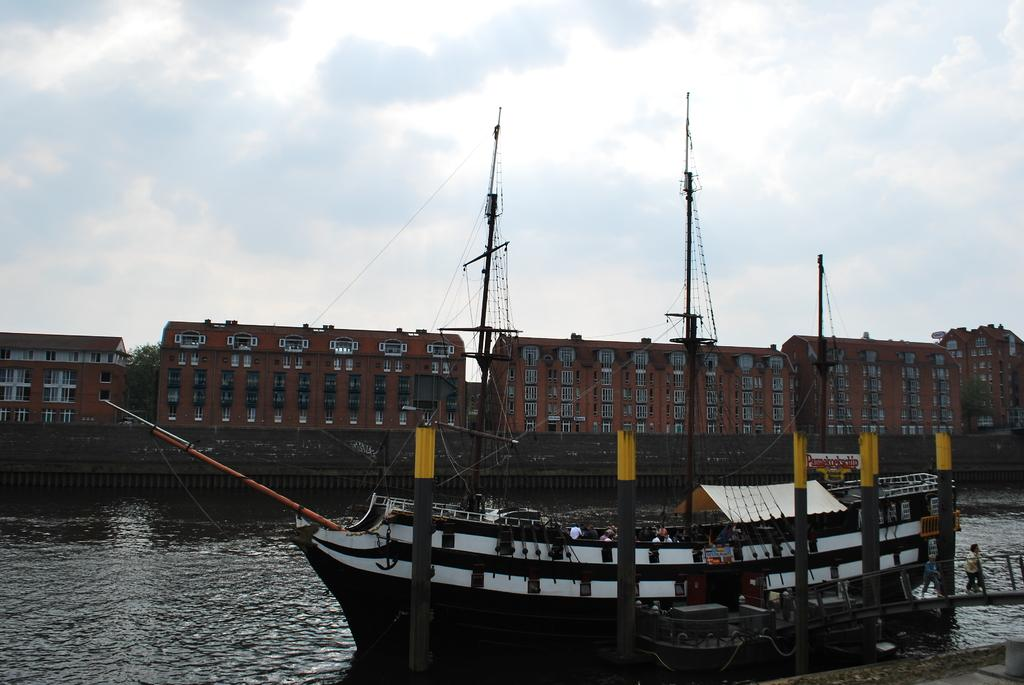What is the main subject of the image? The main subject of the image is a ship. Where is the ship located? The ship is on the water. Are there any people on the ship? Yes, there are people on the ship. What can be seen in the background of the image? In the background of the image, there are buildings, trees, and clouds. What type of mine can be seen in the image? There is no mine present in the image; it features a ship on the water with people on board and a background of buildings, trees, and clouds. What statement is being made by the ship in the image? Ships do not make statements; they are inanimate objects. 